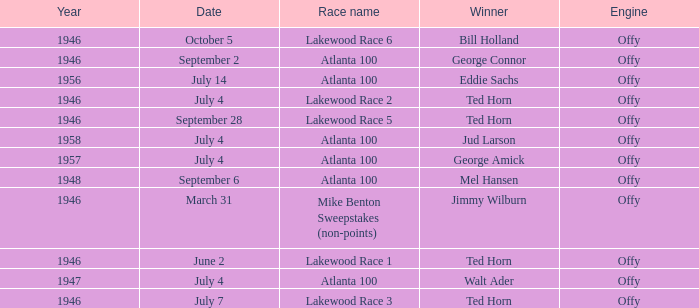Which race did Bill Holland win in 1946? Lakewood Race 6. 